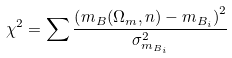<formula> <loc_0><loc_0><loc_500><loc_500>\chi ^ { 2 } = \sum \frac { \left ( m _ { B } ( \Omega _ { m } , n ) - m _ { B _ { i } } \right ) ^ { 2 } } { \sigma ^ { 2 } _ { m _ { B _ { i } } } }</formula> 